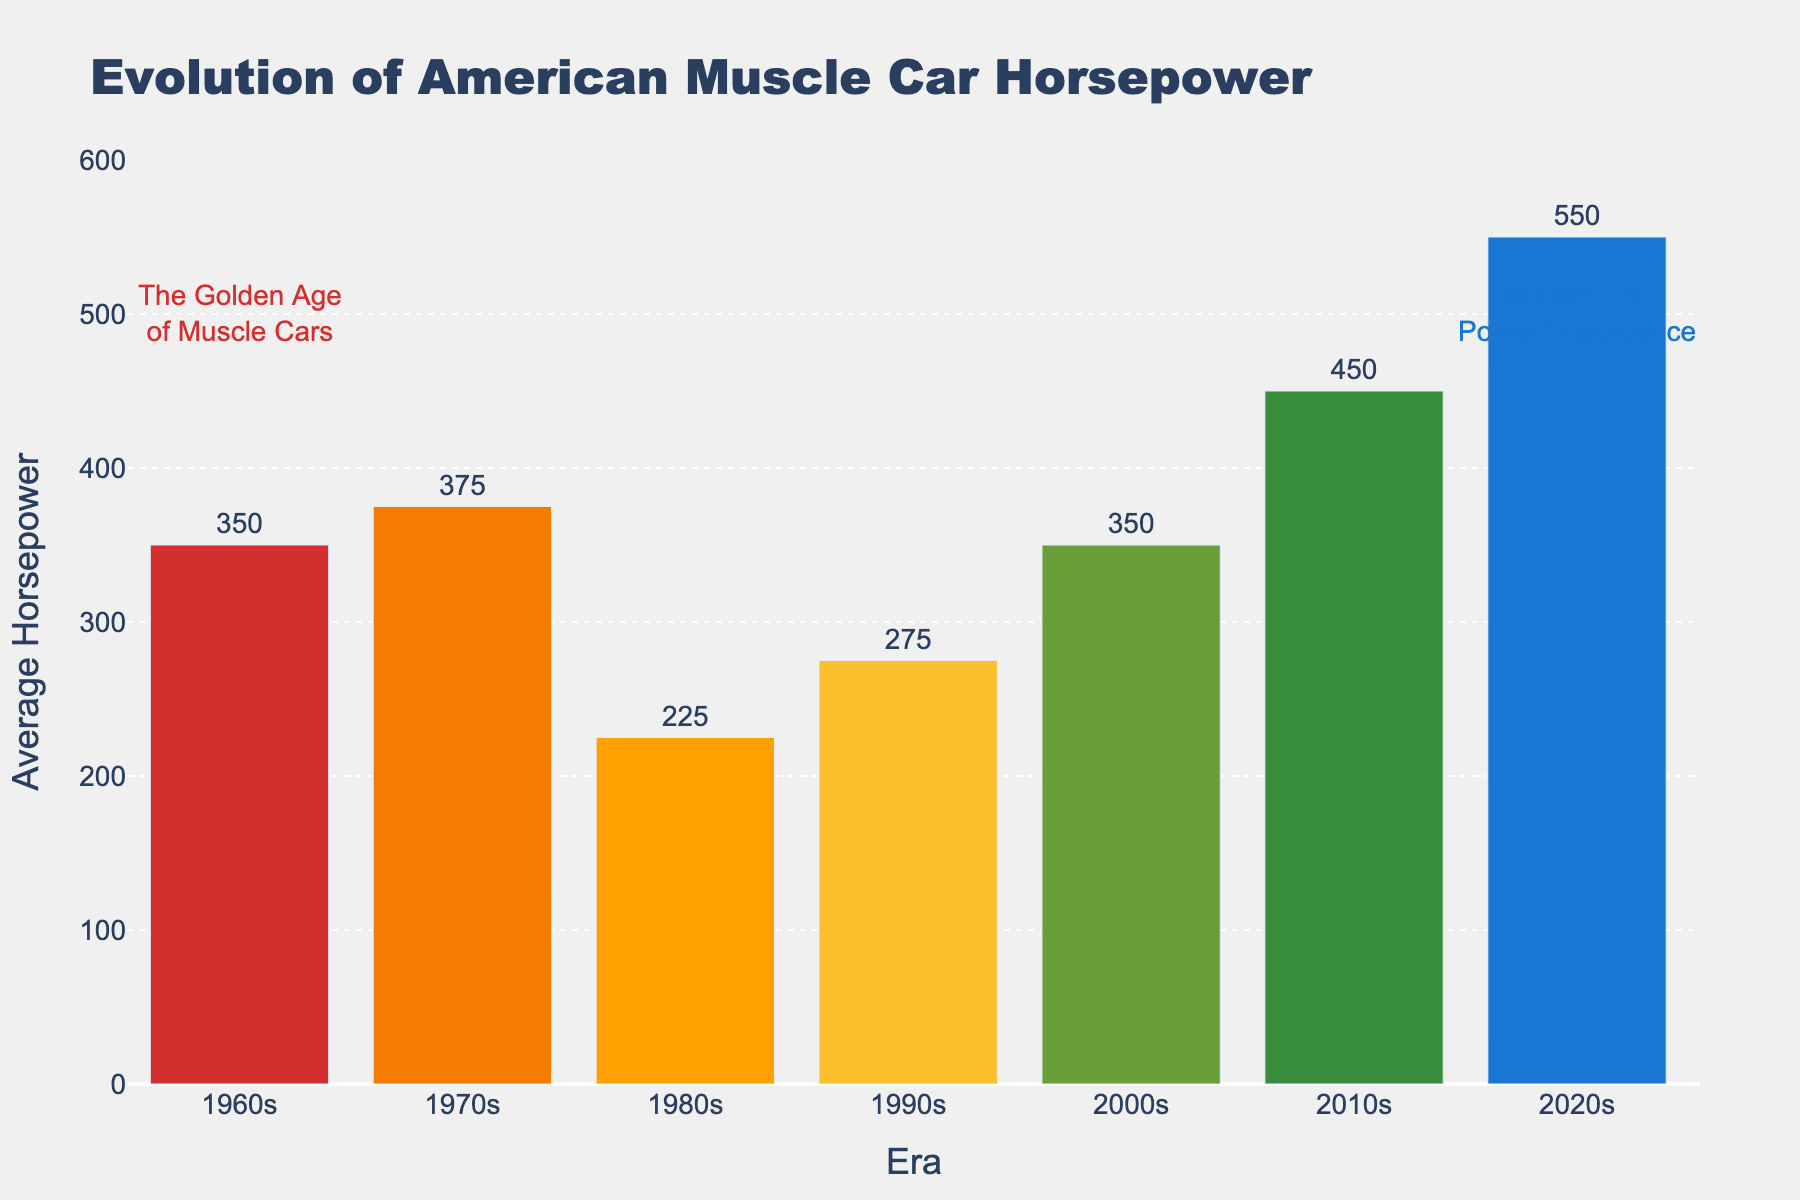What is the average horsepower of American muscle cars in the 2010s? Identify the bar labeled "2010s" and read the value on top of the bar, which represents the average horsepower for that era.
Answer: 450 By how much did the average horsepower decrease from the 1970s to the 1980s? Find the average horsepower for the 1970s (375) and the 1980s (225). Subtract the 1980s value from the 1970s value: 375 - 225 = 150.
Answer: 150 Which era has the highest average horsepower? Look for the tallest bar on the chart, which corresponds to the 2020s era with 550 horsepower.
Answer: 2020s Compare the average horsepower between the 1960s and the 2000s. Which era had a higher horsepower and by how much? Find the average horsepower for the 1960s (350) and the 2000s (350). Both values are equal, so the difference is 0.
Answer: Both 1960s and 2000s, 0 difference What is the trend in average horsepower from the 1980s to the 2020s? Observe the bars from the 1980s to the 2020s: 225 (1980s), 275 (1990s), 350 (2000s), 450 (2010s), and 550 (2020s). The trend is an increase in average horsepower over these eras.
Answer: Increasing How does the average horsepower in the 1990s compare to that in the 1960s? Locate the bars for the 1990s (275) and the 1960s (350). The 1960s has higher horsepower. Subtract the 1990s value from the 1960s value: 350 - 275 = 75.
Answer: 1960s by 75 Identify the era with the lowest average horsepower. Look for the shortest bar on the chart, which corresponds to the 1980s with 225 horsepower.
Answer: 1980s What's the total average horsepower summed across the 1960s and 2010s? Sum the values for the 1960s (350) and the 2010s (450): 350 + 450 = 800.
Answer: 800 What can be inferred from the annotations regarding the "Golden Age of Muscle Cars" and the "Modern Era: Power Resurgence"? The annotations suggest that the 1960s are considered the "Golden Age" of muscle cars, and the 2020s represent a resurgence in muscle car power.
Answer: 1960s, 2020s Which era saw the biggest jump in average horsepower compared to the previous era? Calculate the differences between consecutive eras: 
- 1960s to 1970s: 375 - 350 = 25 
- 1970s to 1980s: 225 - 375 = -150 
- 1980s to 1990s: 275 - 225 = 50 
- 1990s to 2000s: 350 - 275 = 75 
- 2000s to 2010s: 450 - 350 = 100 
- 2010s to 2020s: 550 - 450 = 100 
Sort the differences to find that the biggest jump is 100, seen in both 2000s to 2010s and 2010s to 2020s.
Answer: 2000s to 2010s, 2010s to 2020s 